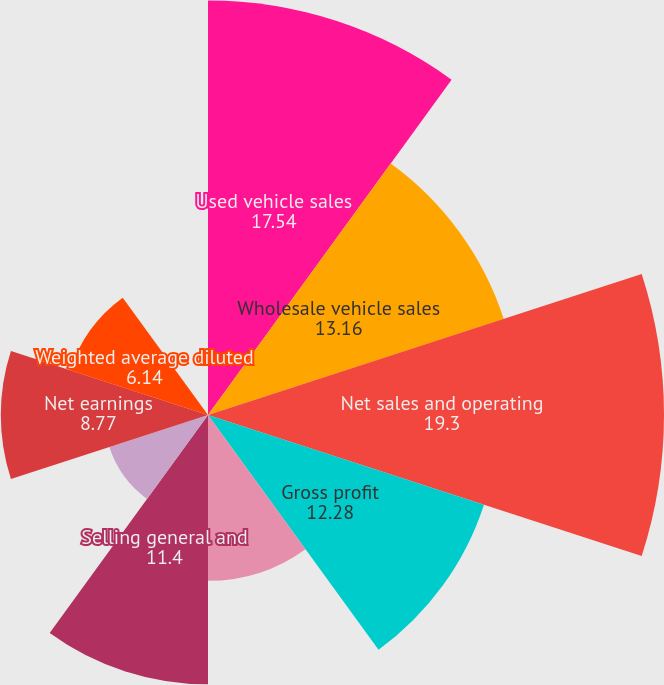Convert chart to OTSL. <chart><loc_0><loc_0><loc_500><loc_500><pie_chart><fcel>Used vehicle sales<fcel>Wholesale vehicle sales<fcel>Net sales and operating<fcel>Gross profit<fcel>CarMax Auto Finance income<fcel>Selling general and<fcel>Interest expense<fcel>Net earnings<fcel>Weighted average diluted<fcel>Diluted net earnings per share<nl><fcel>17.54%<fcel>13.16%<fcel>19.3%<fcel>12.28%<fcel>7.02%<fcel>11.4%<fcel>4.39%<fcel>8.77%<fcel>6.14%<fcel>0.0%<nl></chart> 